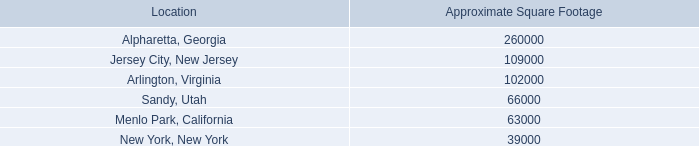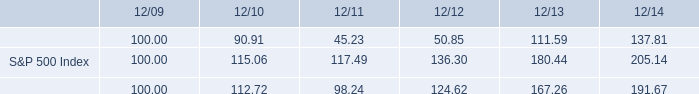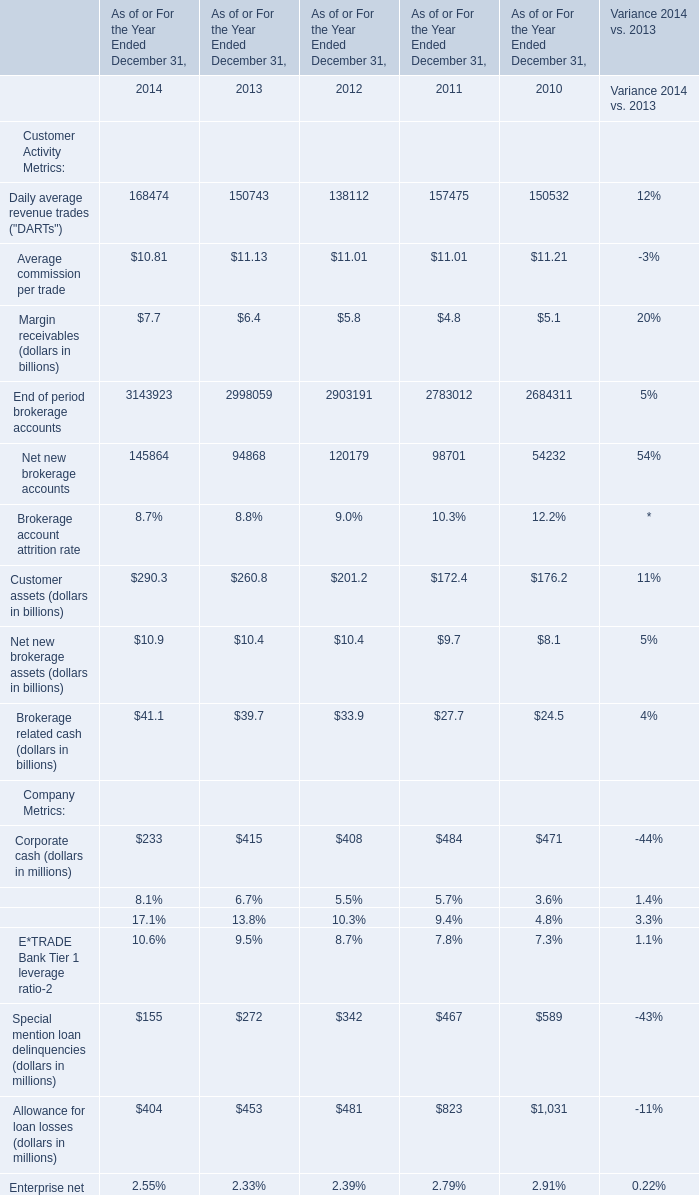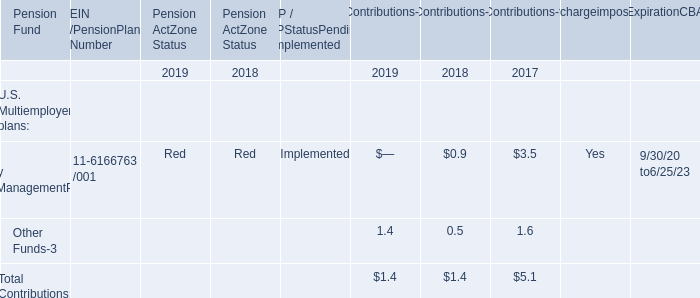what was the ratio of the s&p index to the e*trade financial corporation cumulative total return to a holder of the company 2019s common stock compared as of 2014 
Computations: (205.14 / 137.81)
Answer: 1.48857. What is the growing rate of Daily average revenue trades ("DARTs") in the year with the most Net new brokerage accounts? 
Computations: ((168474 - 150743) / 150743)
Answer: 0.11762. 